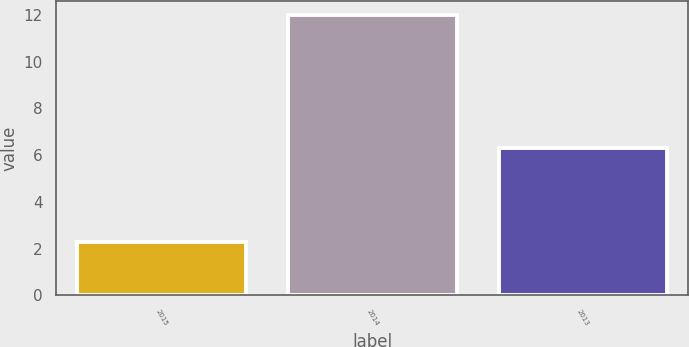Convert chart to OTSL. <chart><loc_0><loc_0><loc_500><loc_500><bar_chart><fcel>2015<fcel>2014<fcel>2013<nl><fcel>2.3<fcel>12<fcel>6.3<nl></chart> 